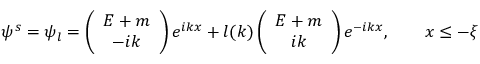Convert formula to latex. <formula><loc_0><loc_0><loc_500><loc_500>\psi ^ { s } = \psi _ { l } = \left ( \begin{array} { c } { E + m } \\ { - i k } \end{array} \right ) e ^ { i k x } + l ( k ) \left ( \begin{array} { c } { E + m } \\ { i k } \end{array} \right ) e ^ { - i k x } , \quad x \leq - \xi</formula> 